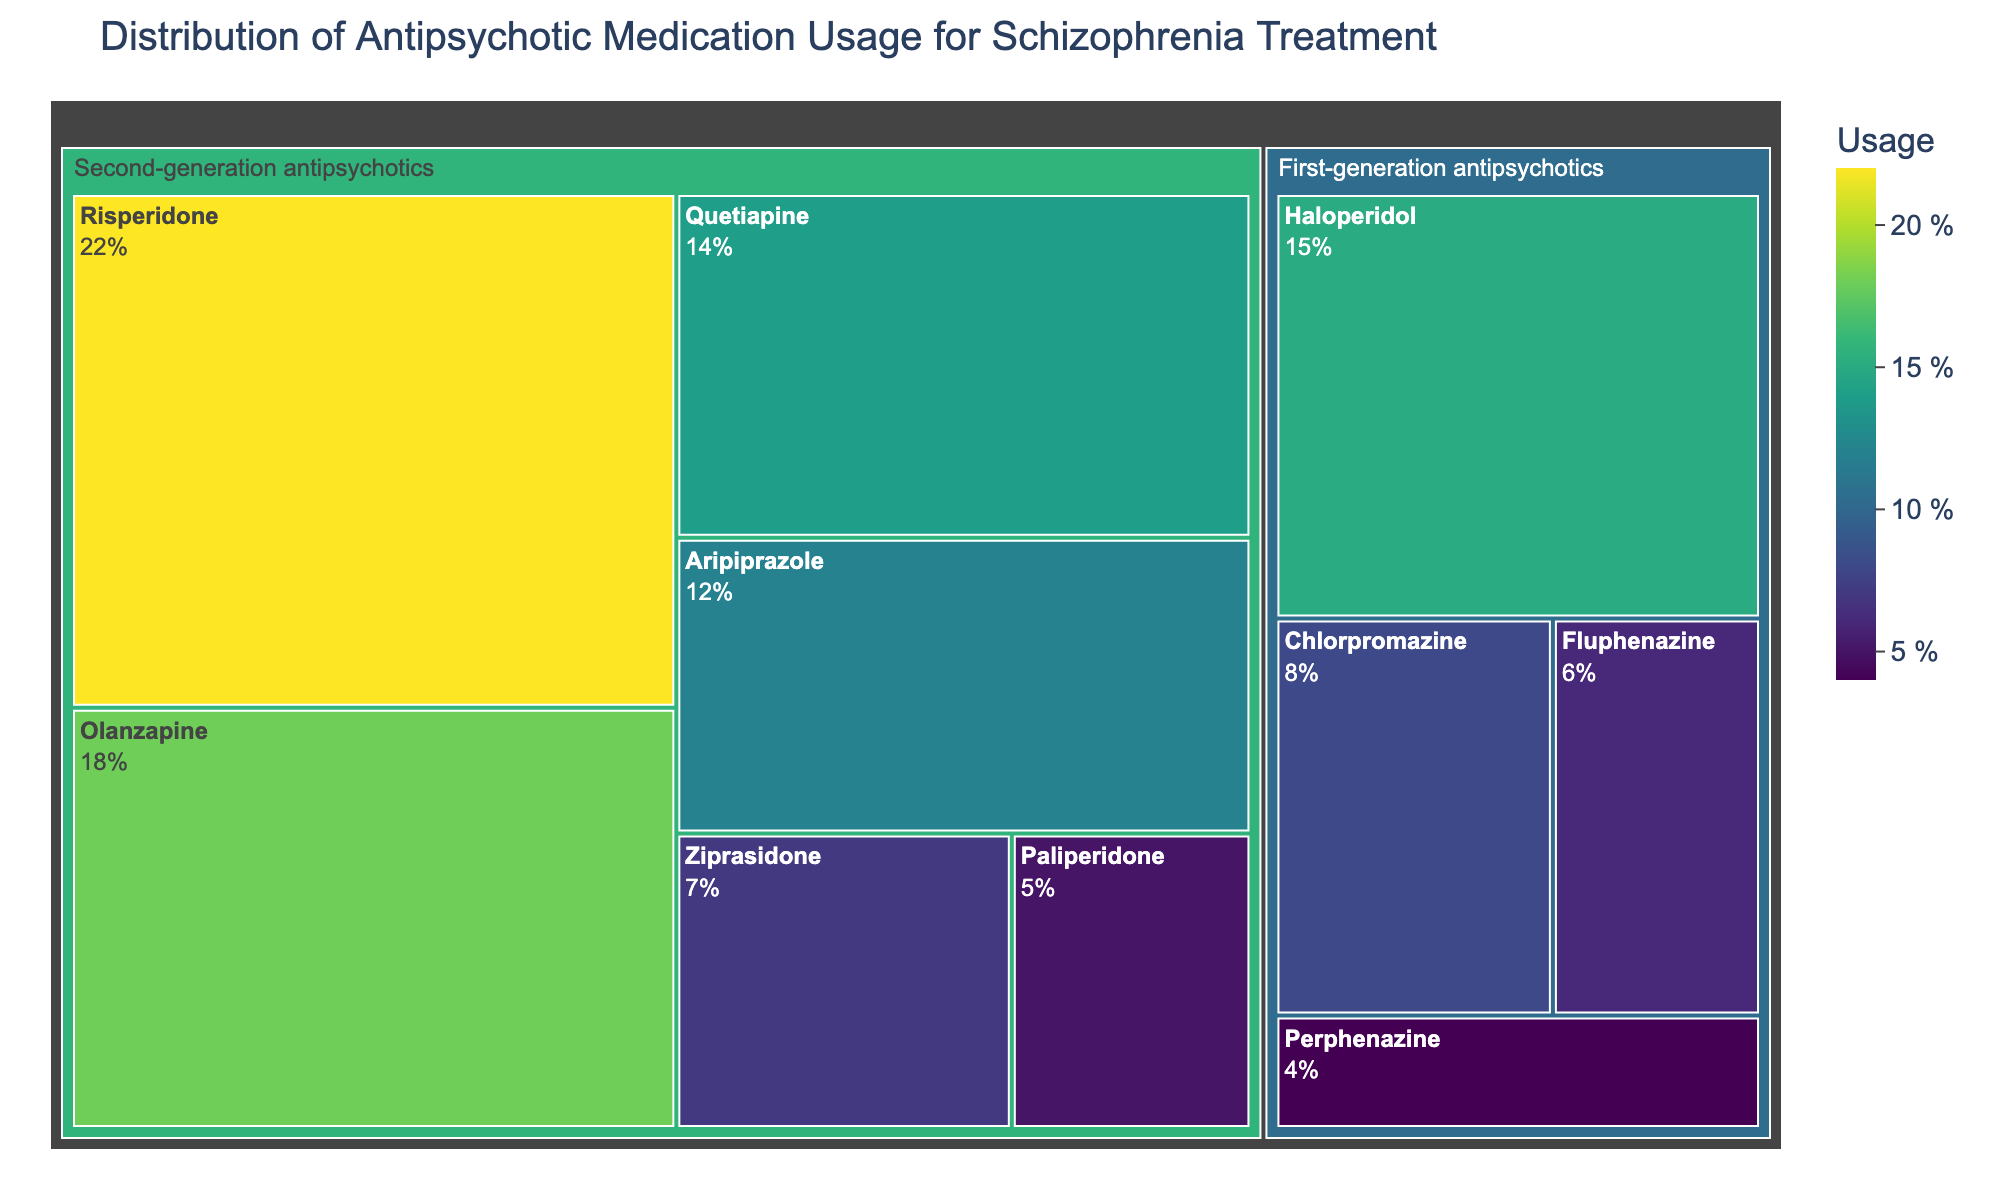What is the most commonly used medication according to the treemap? By looking at the largest segment in the treemap, which has the highest usage percentage, we can identify the most commonly used medication. In this case, the largest segment represents Risperidone with a usage of 22%.
Answer: Risperidone What is the usage percentage of Haloperidol? To find the usage percentage of Haloperidol, locate its segment in the treemap under the "First-generation antipsychotics" category. The segment indicates a usage percentage of 15%.
Answer: 15% How does the usage of first-generation antipsychotics compare to second-generation antipsychotics overall? Summing the usage percentages of all first-generation antipsychotics (Haloperidol, Chlorpromazine, Fluphenazine, Perphenazine) and comparing it to the sum of all second-generation antipsychotics (Risperidone, Olanzapine, Quetiapine, Aripiprazole, Ziprasidone, Paliperidone), we find that second-generation antipsychotics have a higher overall usage. First-generation total: 15 + 8 + 6 + 4 = 33%. Second-generation total: 22 + 18 + 14 + 12 + 7 + 5 = 78%.
Answer: Second-generation antipsychotics have a higher usage Which medication has the lowest usage among second-generation antipsychotics? By locating the smallest segment within the second-generation antipsychotics category, we see that Paliperidone has the lowest usage at 5%.
Answer: Paliperidone What is the difference in usage between Olanzapine and Quetiapine? Subtract Quetiapine's usage percentage from Olanzapine's usage percentage. Olanzapine has 18% and Quetiapine has 14%. The difference is 18% - 14% = 4%.
Answer: 4% Which category, first-generation or second-generation antipsychotics, has a greater number of unique medications listed? Count the number of unique medications under each category. First-generation has 4 (Haloperidol, Chlorpromazine, Fluphenazine, Perphenazine) and second-generation has 6 (Risperidone, Olanzapine, Quetiapine, Aripiprazole, Ziprasidone, Paliperidone). Therefore, second-generation antipsychotics have more unique medications listed.
Answer: Second-generation What is the combined usage percentage of all medications under first-generation antipsychotics? Add the individual usage percentages for all first-generation antipsychotics: Haloperidol (15%), Chlorpromazine (8%), Fluphenazine (6%), Perphenazine (4%). The combined usage is 15 + 8 + 6 + 4 = 33%.
Answer: 33% Which medication has the highest usage among first-generation antipsychotics? Within the first-generation antipsychotics category, identify the medication with the largest segment. Haloperidol, with a usage of 15%, has the highest usage.
Answer: Haloperidol 